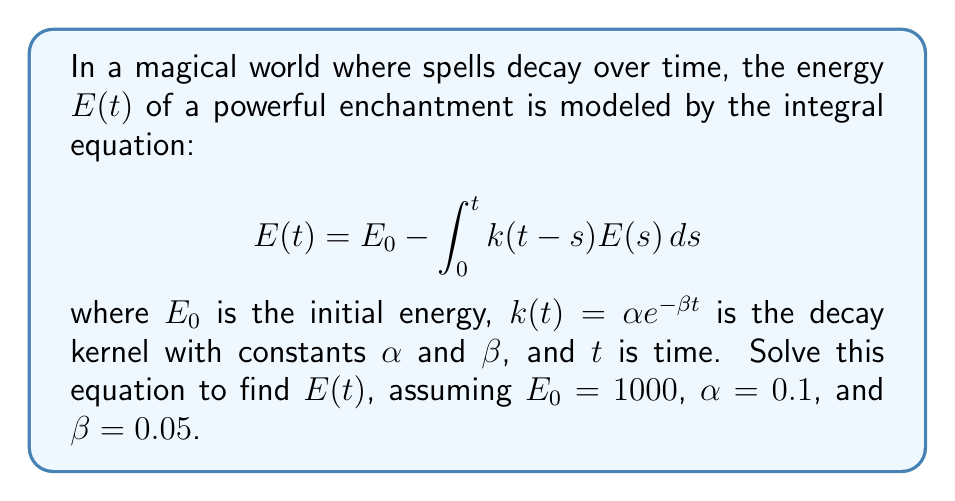Help me with this question. 1) First, we recognize this as a Volterra integral equation of the second kind.

2) To solve it, we can use the Laplace transform method. Let $\mathcal{L}\{E(t)\} = \bar{E}(p)$.

3) Taking the Laplace transform of both sides:

   $$\bar{E}(p) = \frac{E_0}{p} - \mathcal{L}\{k(t)\}\bar{E}(p)$$

4) The Laplace transform of $k(t) = \alpha e^{-\beta t}$ is $\frac{\alpha}{p+\beta}$.

5) Substituting and rearranging:

   $$\bar{E}(p)\left(1 + \frac{\alpha}{p+\beta}\right) = \frac{E_0}{p}$$

   $$\bar{E}(p) = \frac{E_0}{p}\cdot\frac{p+\beta}{p+\beta+\alpha}$$

6) This can be rewritten as:

   $$\bar{E}(p) = \frac{E_0}{p} - \frac{E_0\alpha}{p(p+\beta+\alpha)}$$

7) Taking the inverse Laplace transform:

   $$E(t) = E_0 - E_0\alpha\int_0^t e^{-(\beta+\alpha)(t-s)}ds$$

8) Solving the integral:

   $$E(t) = E_0 - \frac{E_0\alpha}{\beta+\alpha}(1-e^{-(\beta+\alpha)t})$$

9) Substituting the given values $E_0 = 1000$, $\alpha = 0.1$, and $\beta = 0.05$:

   $$E(t) = 1000 - \frac{1000 \cdot 0.1}{0.05+0.1}(1-e^{-(0.05+0.1)t})$$

   $$E(t) = 1000 - 666.67(1-e^{-0.15t})$$
Answer: $E(t) = 1000 - 666.67(1-e^{-0.15t})$ 